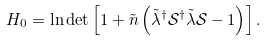Convert formula to latex. <formula><loc_0><loc_0><loc_500><loc_500>H _ { 0 } = \ln \det \left [ 1 + \tilde { n } \left ( \tilde { \lambda } ^ { \dagger } \mathcal { S } ^ { \dagger } \tilde { \lambda } \mathcal { S } - 1 \right ) \right ] .</formula> 